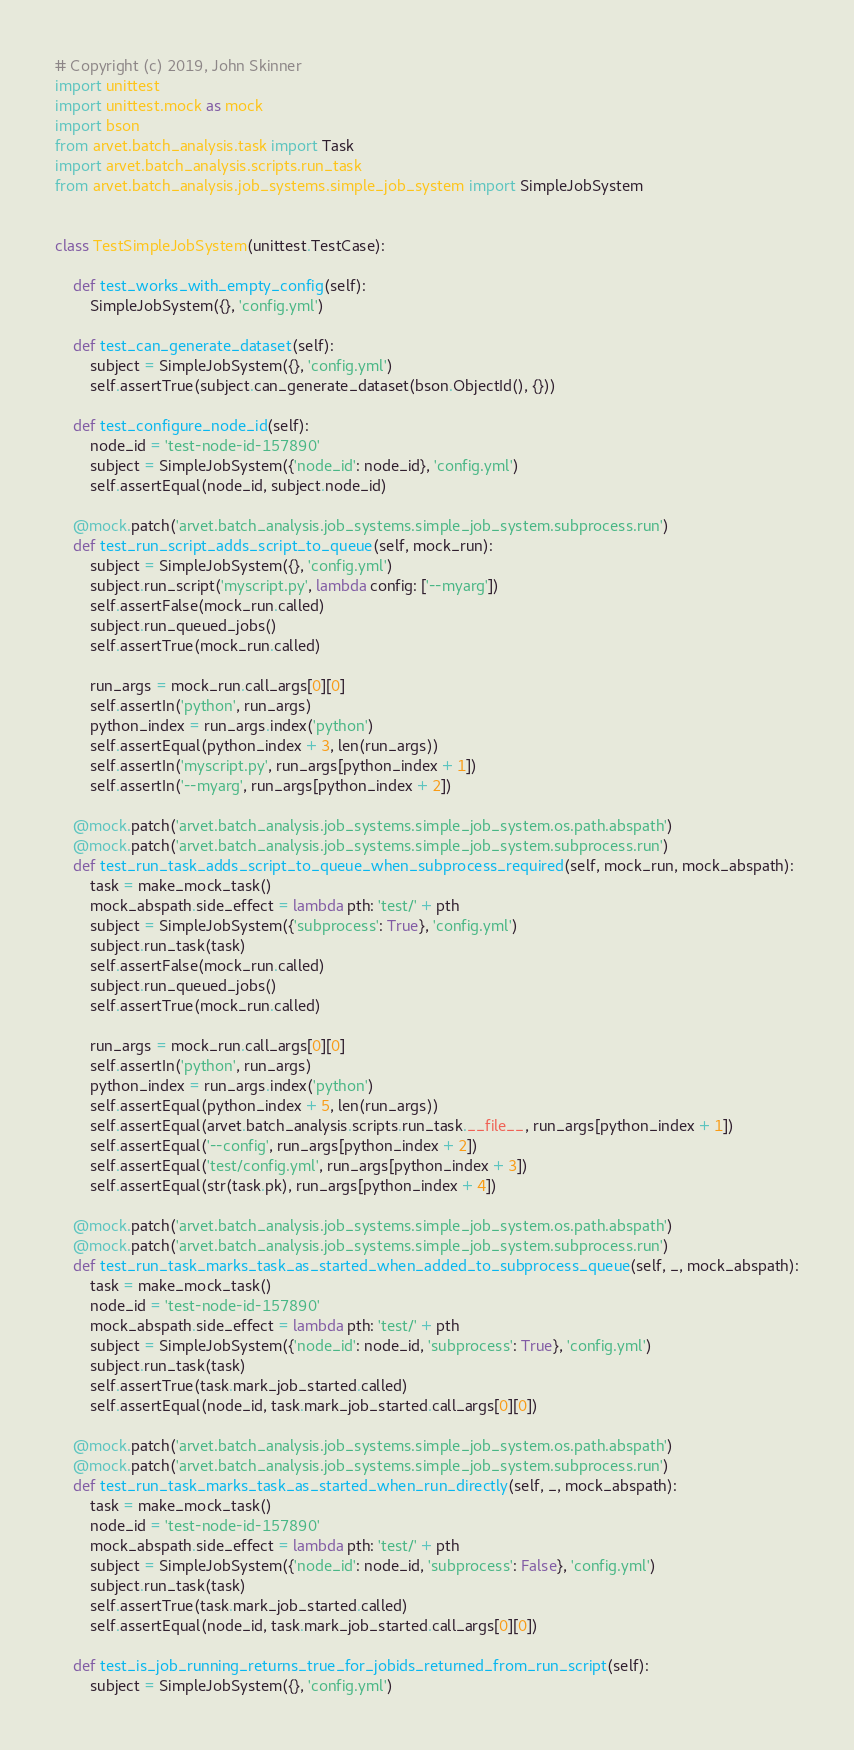<code> <loc_0><loc_0><loc_500><loc_500><_Python_># Copyright (c) 2019, John Skinner
import unittest
import unittest.mock as mock
import bson
from arvet.batch_analysis.task import Task
import arvet.batch_analysis.scripts.run_task
from arvet.batch_analysis.job_systems.simple_job_system import SimpleJobSystem


class TestSimpleJobSystem(unittest.TestCase):

    def test_works_with_empty_config(self):
        SimpleJobSystem({}, 'config.yml')

    def test_can_generate_dataset(self):
        subject = SimpleJobSystem({}, 'config.yml')
        self.assertTrue(subject.can_generate_dataset(bson.ObjectId(), {}))

    def test_configure_node_id(self):
        node_id = 'test-node-id-157890'
        subject = SimpleJobSystem({'node_id': node_id}, 'config.yml')
        self.assertEqual(node_id, subject.node_id)

    @mock.patch('arvet.batch_analysis.job_systems.simple_job_system.subprocess.run')
    def test_run_script_adds_script_to_queue(self, mock_run):
        subject = SimpleJobSystem({}, 'config.yml')
        subject.run_script('myscript.py', lambda config: ['--myarg'])
        self.assertFalse(mock_run.called)
        subject.run_queued_jobs()
        self.assertTrue(mock_run.called)

        run_args = mock_run.call_args[0][0]
        self.assertIn('python', run_args)
        python_index = run_args.index('python')
        self.assertEqual(python_index + 3, len(run_args))
        self.assertIn('myscript.py', run_args[python_index + 1])
        self.assertIn('--myarg', run_args[python_index + 2])

    @mock.patch('arvet.batch_analysis.job_systems.simple_job_system.os.path.abspath')
    @mock.patch('arvet.batch_analysis.job_systems.simple_job_system.subprocess.run')
    def test_run_task_adds_script_to_queue_when_subprocess_required(self, mock_run, mock_abspath):
        task = make_mock_task()
        mock_abspath.side_effect = lambda pth: 'test/' + pth
        subject = SimpleJobSystem({'subprocess': True}, 'config.yml')
        subject.run_task(task)
        self.assertFalse(mock_run.called)
        subject.run_queued_jobs()
        self.assertTrue(mock_run.called)

        run_args = mock_run.call_args[0][0]
        self.assertIn('python', run_args)
        python_index = run_args.index('python')
        self.assertEqual(python_index + 5, len(run_args))
        self.assertEqual(arvet.batch_analysis.scripts.run_task.__file__, run_args[python_index + 1])
        self.assertEqual('--config', run_args[python_index + 2])
        self.assertEqual('test/config.yml', run_args[python_index + 3])
        self.assertEqual(str(task.pk), run_args[python_index + 4])

    @mock.patch('arvet.batch_analysis.job_systems.simple_job_system.os.path.abspath')
    @mock.patch('arvet.batch_analysis.job_systems.simple_job_system.subprocess.run')
    def test_run_task_marks_task_as_started_when_added_to_subprocess_queue(self, _, mock_abspath):
        task = make_mock_task()
        node_id = 'test-node-id-157890'
        mock_abspath.side_effect = lambda pth: 'test/' + pth
        subject = SimpleJobSystem({'node_id': node_id, 'subprocess': True}, 'config.yml')
        subject.run_task(task)
        self.assertTrue(task.mark_job_started.called)
        self.assertEqual(node_id, task.mark_job_started.call_args[0][0])

    @mock.patch('arvet.batch_analysis.job_systems.simple_job_system.os.path.abspath')
    @mock.patch('arvet.batch_analysis.job_systems.simple_job_system.subprocess.run')
    def test_run_task_marks_task_as_started_when_run_directly(self, _, mock_abspath):
        task = make_mock_task()
        node_id = 'test-node-id-157890'
        mock_abspath.side_effect = lambda pth: 'test/' + pth
        subject = SimpleJobSystem({'node_id': node_id, 'subprocess': False}, 'config.yml')
        subject.run_task(task)
        self.assertTrue(task.mark_job_started.called)
        self.assertEqual(node_id, task.mark_job_started.call_args[0][0])

    def test_is_job_running_returns_true_for_jobids_returned_from_run_script(self):
        subject = SimpleJobSystem({}, 'config.yml')</code> 